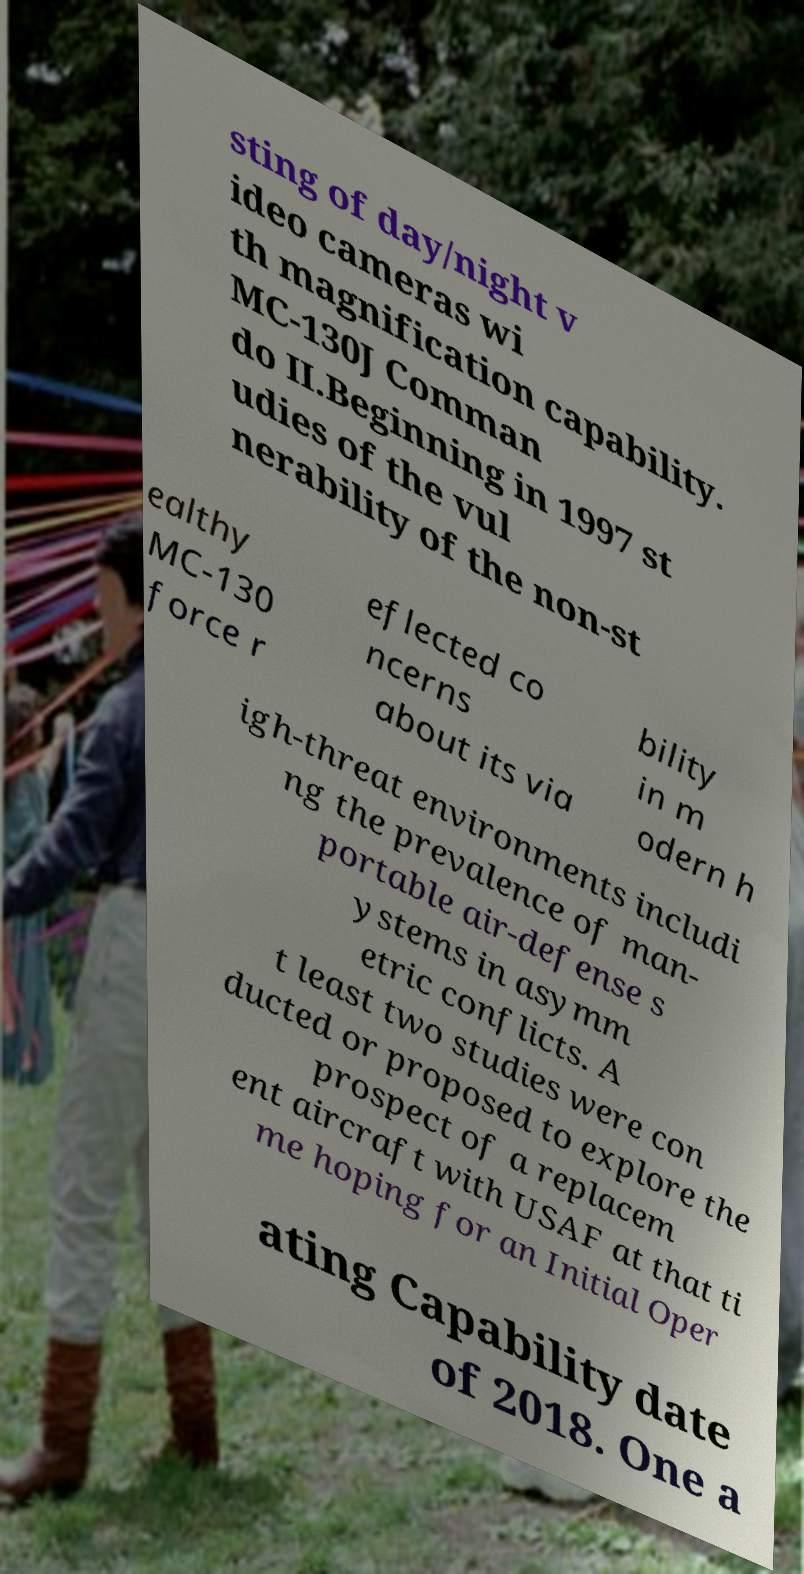For documentation purposes, I need the text within this image transcribed. Could you provide that? sting of day/night v ideo cameras wi th magnification capability. MC-130J Comman do II.Beginning in 1997 st udies of the vul nerability of the non-st ealthy MC-130 force r eflected co ncerns about its via bility in m odern h igh-threat environments includi ng the prevalence of man- portable air-defense s ystems in asymm etric conflicts. A t least two studies were con ducted or proposed to explore the prospect of a replacem ent aircraft with USAF at that ti me hoping for an Initial Oper ating Capability date of 2018. One a 